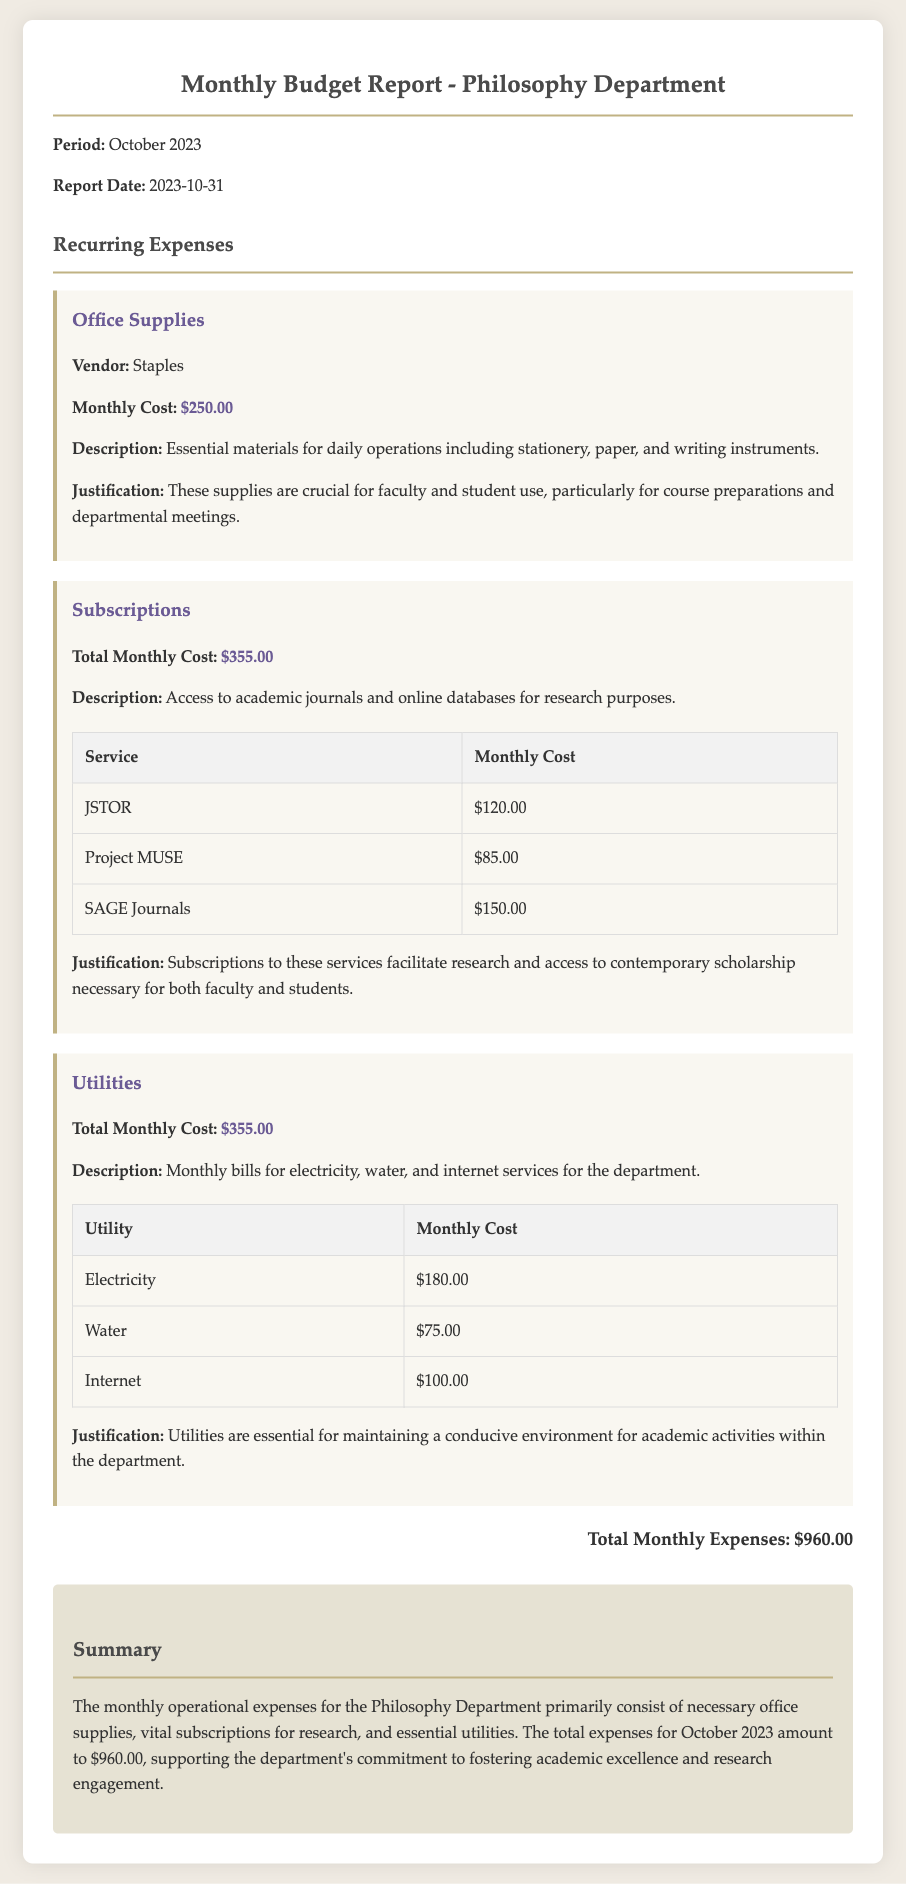What is the report date? The report date is specified in the document, which is 2023-10-31.
Answer: 2023-10-31 What is the total monthly cost for office supplies? The document lists the monthly cost for office supplies as $250.00.
Answer: $250.00 What is the total amount for subscriptions? The document shows that the total monthly cost for subscriptions is $355.00.
Answer: $355.00 What is the total monthly cost for utilities? The total monthly cost for utilities is detailed in the document as $355.00.
Answer: $355.00 What is the total monthly expense for the department? The total monthly expenses for the Philosophy Department are summed up at $960.00.
Answer: $960.00 Which vendor provides office supplies? The vendor providing office supplies is mentioned in the document as Staples.
Answer: Staples What types of utilities are listed in the report? The types of utilities mentioned are electricity, water, and internet services.
Answer: Electricity, water, internet What is the justification for office supplies? The justification provided for office supplies indicates their importance for daily operations, course preparations, and meetings.
Answer: Crucial for faculty and student use How many subscriptions are detailed in the report? The number of subscriptions listed in the document is three.
Answer: Three What is the primary purpose of the subscriptions? The primary purpose of the subscriptions is for access to academic journals and online databases for research.
Answer: Academic journals and online databases 